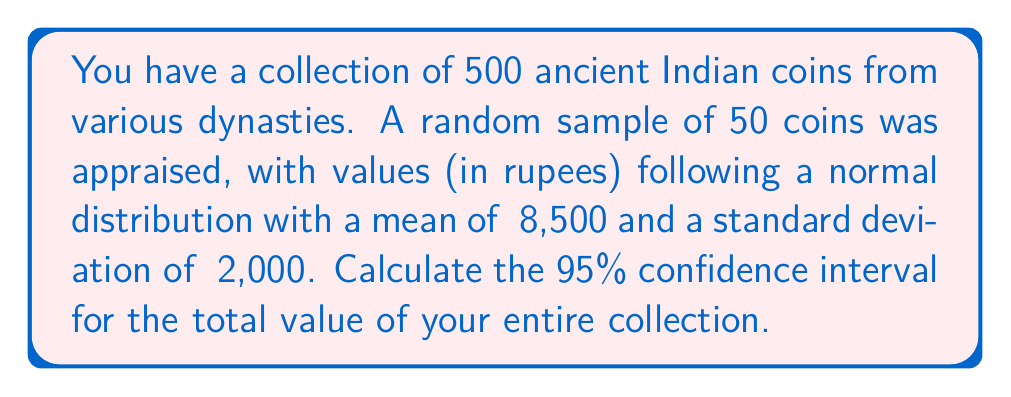Provide a solution to this math problem. Let's approach this step-by-step:

1) First, we need to find the standard error of the mean. The formula is:

   $SE = \frac{s}{\sqrt{n}}$

   Where $s$ is the sample standard deviation and $n$ is the sample size.

   $SE = \frac{2000}{\sqrt{50}} = 282.84$

2) For a 95% confidence interval, we use a z-score of 1.96 (from the standard normal distribution table).

3) The margin of error is calculated as:

   $ME = z \times SE = 1.96 \times 282.84 = 554.37$

4) The 95% confidence interval for the mean value of a single coin is:

   $(\bar{x} - ME, \bar{x} + ME) = (8500 - 554.37, 8500 + 554.37) = (7945.63, 9054.37)$

5) To estimate the total value of the collection, we multiply these bounds by the total number of coins (500):

   Lower bound: $7945.63 \times 500 = 3,972,815$
   Upper bound: $9054.37 \times 500 = 4,527,185$

Therefore, the 95% confidence interval for the total value of the collection is (₹3,972,815, ₹4,527,185).
Answer: (₹3,972,815, ₹4,527,185) 